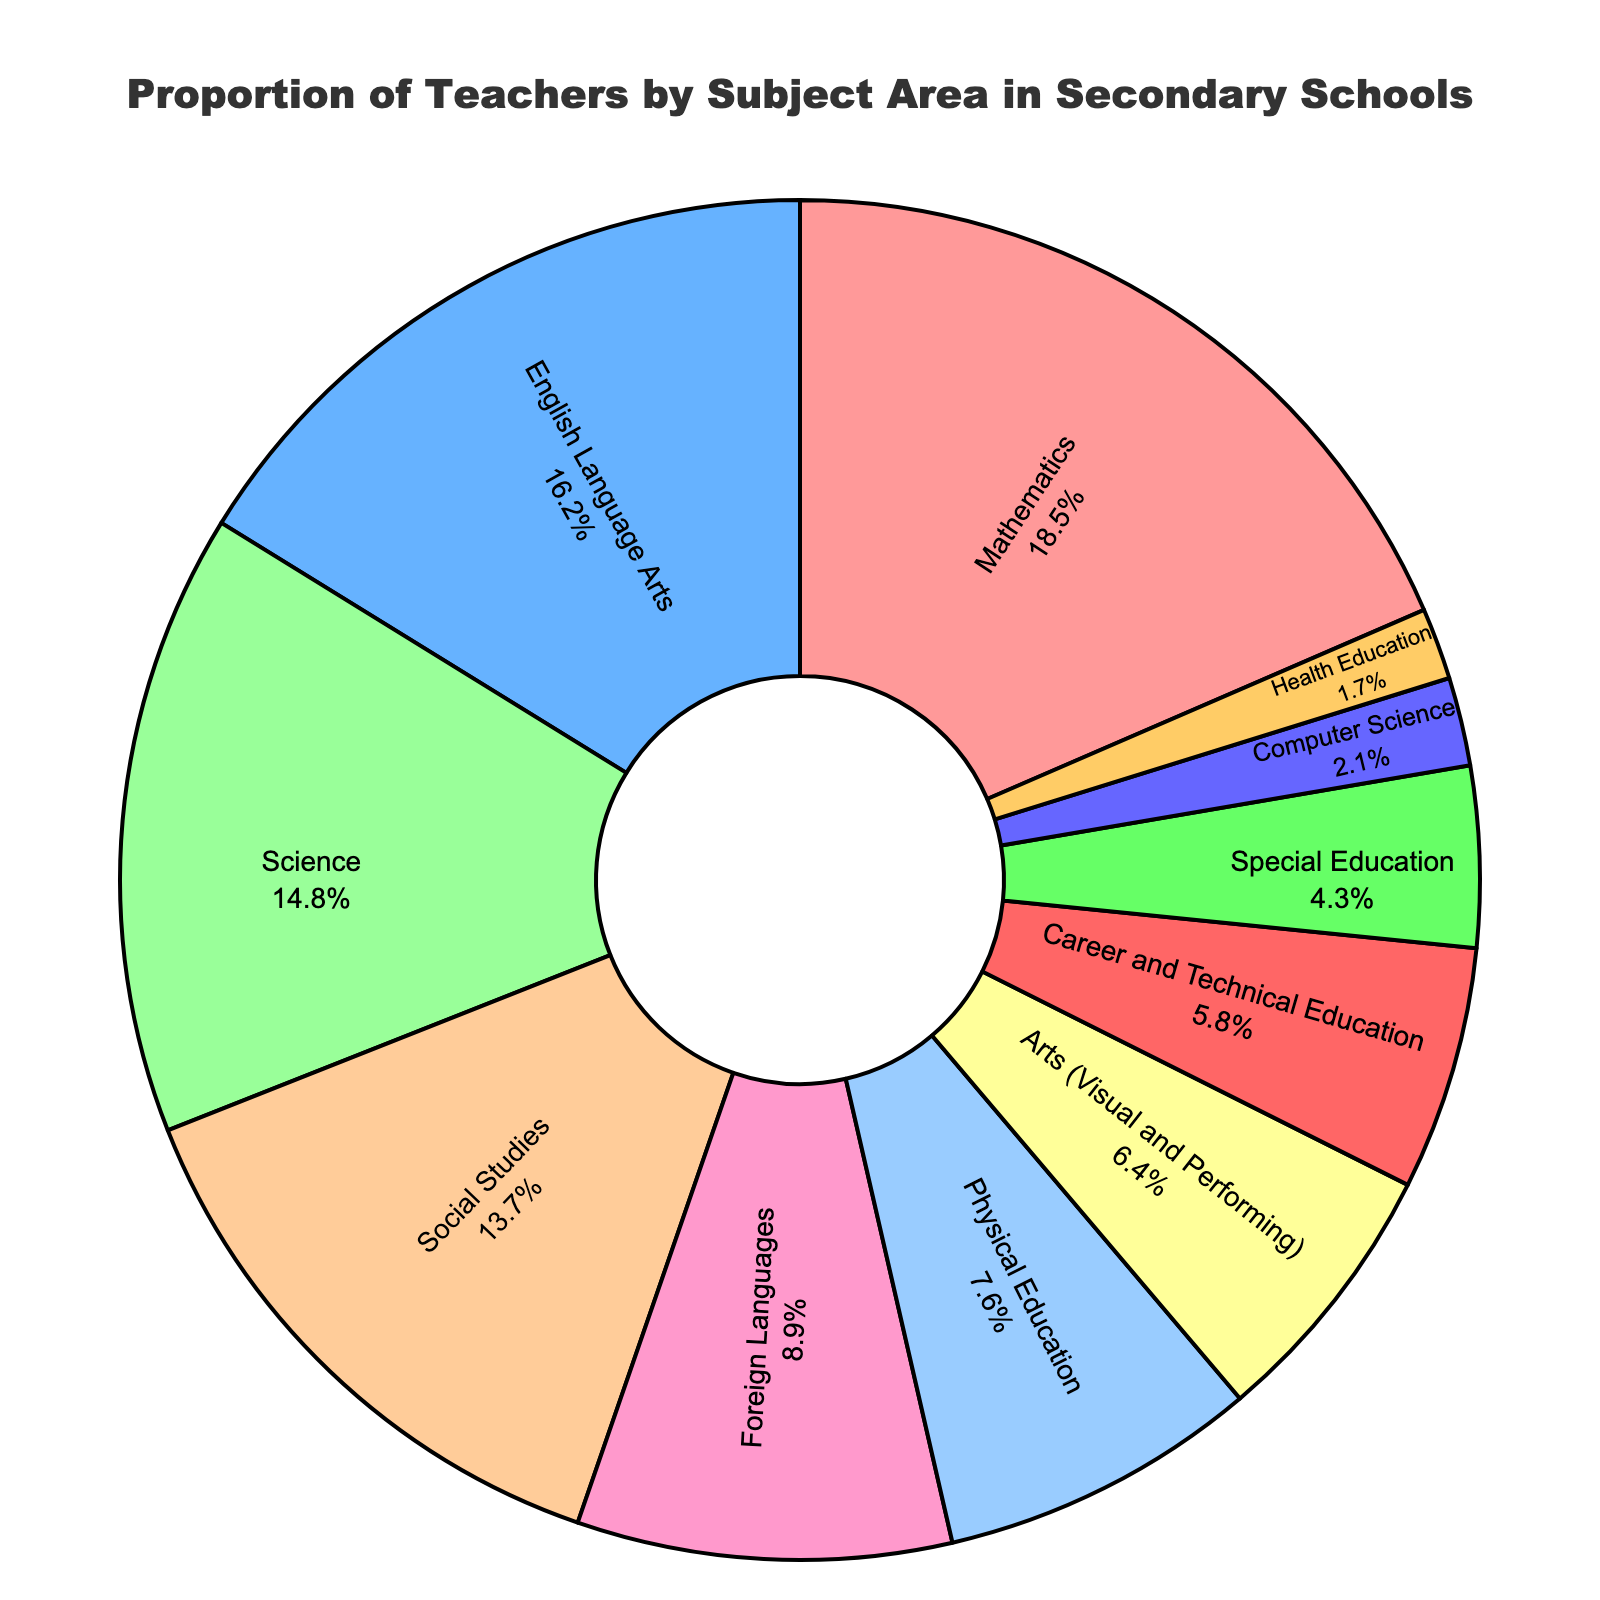What percentage of secondary school teachers specialize in Mathematics? The pie chart shows that the segment labeled "Mathematics" represents 18.5%.
Answer: 18.5% Which subject area has the smallest proportion of teachers? By looking at the segments, "Health Education" has the smallest size, indicating it has the smallest proportion.
Answer: Health Education How does the proportion of Science teachers compare to that of English Language Arts teachers? The proportion of Science teachers is 14.8%, while English Language Arts teachers are 16.2%. Science has a lower proportion.
Answer: Science has a lower proportion What is the total percentage of teachers specializing in Arts and Physical Education combined? Add the percentages of Arts (Visual and Performing) and Physical Education: 6.4% + 7.6% = 14%.
Answer: 14% What is the difference in the proportion of teachers between Social Studies and Foreign Languages? Subtract the percentage of Foreign Languages from Social Studies: 13.7% - 8.9% = 4.8%.
Answer: 4.8% Which subjects have more than 10% of teachers specializing in them? Identify segments larger than 10%, which are Mathematics, English Language Arts, Science, and Social Studies.
Answer: Mathematics, English Language Arts, Science, Social Studies How many times larger is the proportion of Mathematics teachers compared to Computer Science teachers? Divide the percentages of Mathematics by Computer Science: 18.5% / 2.1% ≈ 8.81.
Answer: Approximately 8.81 times larger Is the proportion of teachers specializing in Career and Technical Education greater than those in Special Education? The pie chart shows 5.8% for Career and Technical Education and 4.3% for Special Education. Career and Technical Education has a greater proportion.
Answer: Yes What is the combined proportion of teachers in Foreign Languages, Computer Science, and Health Education? Add the percentages of these subjects: 8.9% + 2.1% + 1.7% = 12.7%.
Answer: 12.7% Which colored segment represents Physical Education teachers? The segment with the color #FF99CC (light pinkish) represents Physical Education teachers.
Answer: Light pinkish segment 